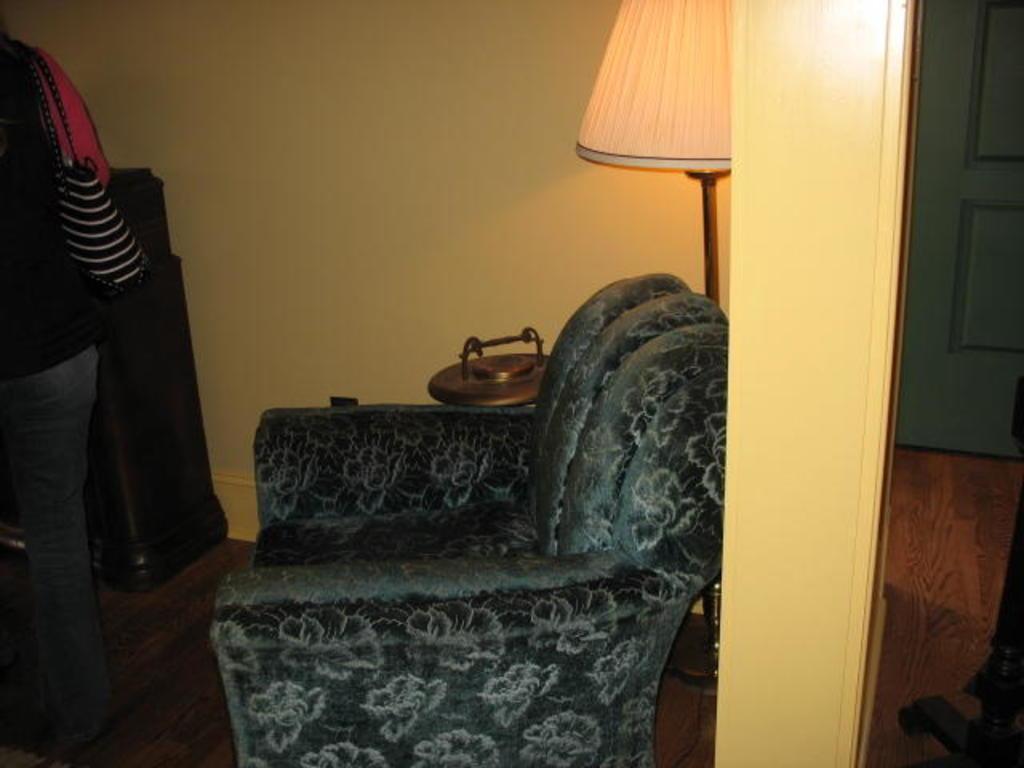In one or two sentences, can you explain what this image depicts? In the center of the image a couch and a lamp are present. On the left side of the image a lady is standing and wearing a bag. On the right side of the image there is a door. At the bottom of the image floor is present. At the top of the image wall is there. 